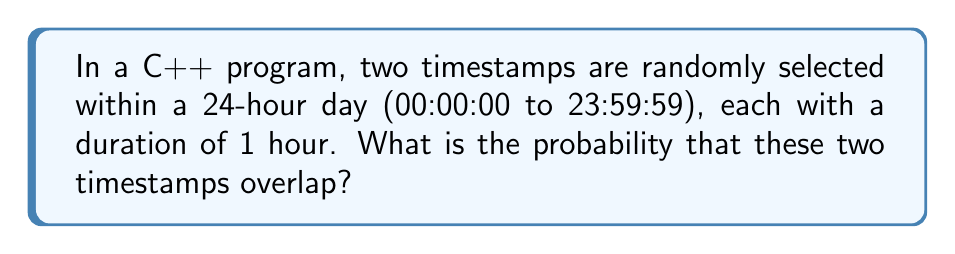Help me with this question. Let's approach this step-by-step:

1) First, we need to understand what it means for two timestamps to overlap. They overlap if the start time of one is within the duration of the other.

2) We can visualize this problem on a number line from 0 to 24 (representing hours in a day). Each timestamp can be represented as a segment of length 1 on this line.

3) For two timestamps not to overlap, the start of the second must be at least 1 hour after the end of the first (or vice versa).

4) Let's consider the first timestamp fixed and calculate the probability of the second not overlapping with it:
   - The first timestamp covers 1 hour out of 24
   - For no overlap, the second must start in the remaining 22 hours (24 - 1 - 1)

5) The probability of no overlap is thus:
   $$P(\text{no overlap}) = \frac{22}{24} = \frac{11}{12}$$

6) Therefore, the probability of overlap is:
   $$P(\text{overlap}) = 1 - P(\text{no overlap}) = 1 - \frac{11}{12} = \frac{1}{12}$$

This result can be verified using the concept of favorable outcomes over total outcomes:
- Total possible pairs of timestamps: $24 * 24 = 576$
- Favorable outcomes (overlapping pairs): $24 * 2 = 48$
- Probability: $\frac{48}{576} = \frac{1}{12}$
Answer: $\frac{1}{12}$ 